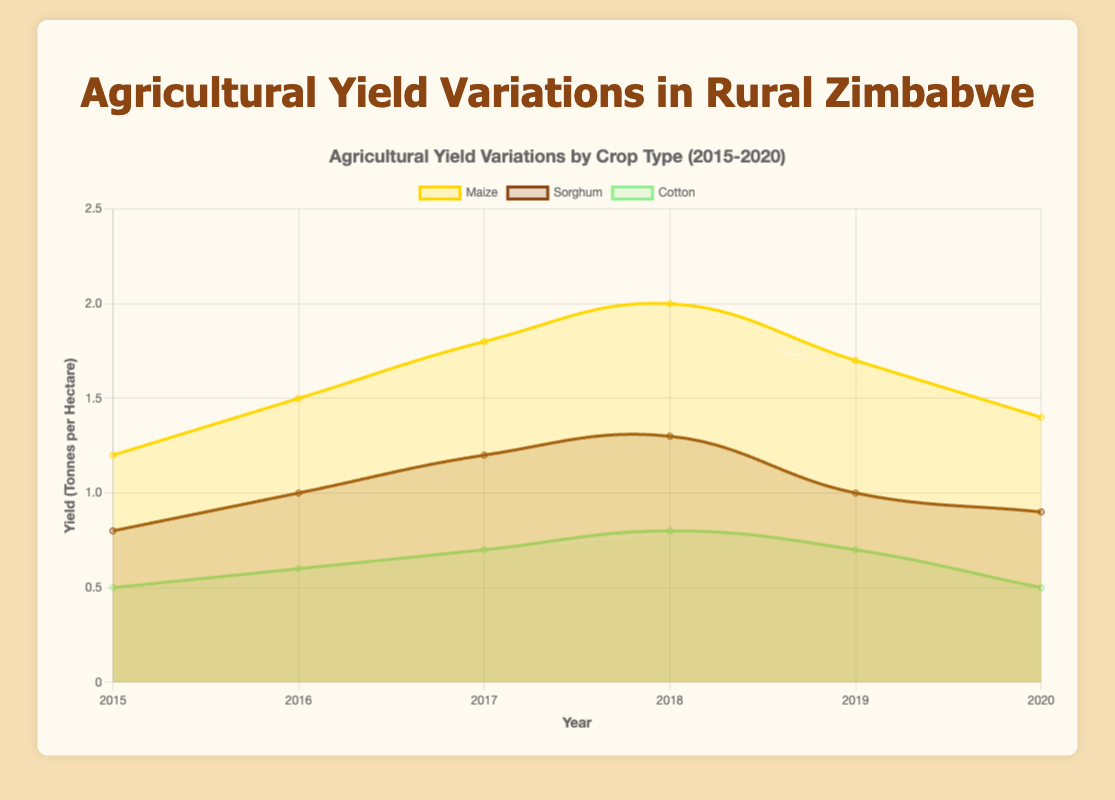Which crop had the highest yield in 2018? To find this, look at the data points for each crop in 2018. The yield for Maize in 2018 is 2.0, Sorghum is 1.3, and Cotton is 0.8.
Answer: Maize How did the yield of Maize change from 2015 to 2020? Check the yield of Maize for each year. In 2015 it was 1.2, in 2016 it was 1.5, in 2017 it was 1.8, in 2018 it was 2.0, in 2019 it was 1.7, and in 2020 it was 1.4.
Answer: Increased initially, then decreased Which crop showed the most consistent yield over the years? Look at the trend lines for each crop. Maize has fluctuations, Sorghum shows a steady increase and slight decrease, and Cotton has small variations.
Answer: Sorghum What was the average yield of Sorghum from 2015 to 2020? Find the yield of Sorghum for each year: 2015 (0.8), 2016 (1.0), 2017 (1.2), 2018 (1.3), 2019 (1.0), 2020 (0.9). Calculate the average: (0.8 + 1.0 + 1.2 + 1.3 + 1.0 + 0.9) / 6 = 6.2 / 6 = 1.03.
Answer: 1.03 Which year had the lowest yield for Cotton? Look at the yield for Cotton each year: 2015 (0.5), 2016 (0.6), 2017 (0.7), 2018 (0.8), 2019 (0.7), and 2020 (0.5). The lowest value is 0.5, present in 2015 and 2020.
Answer: 2015 and 2020 During which year did Maize see the steepest increase in yield? Observe the changes in Maize yield year by year. The largest increase is from 2017 (1.8) to 2018 (2.0), a difference of 0.2.
Answer: 2017 to 2018 Compare the highest yields of Maize and Sorghum. Determine the highest yield for each crop: Maize (2.0 in 2018) and Sorghum (1.3 in 2018).
Answer: Maize What was the difference in yield between Maize and Cotton in 2017? In 2017, the yield for Maize was 1.8 and for Cotton was 0.7. The difference is 1.8 - 0.7 = 1.1.
Answer: 1.1 What colors represent Maize and Cotton on the plot? Identify the colors used for Maize and Cotton lines. Maize is represented by yellow and Cotton is represented by light green.
Answer: Yellow and light green In which year did all three crops have their lowest yields simultaneously? Check the annual yields for all three crops. The lowest yields for Maize (1.2), Sorghum (0.8), and Cotton (0.5) all occur in 2015.
Answer: 2015 